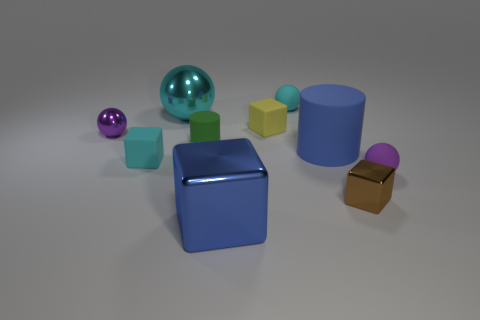Are there fewer large yellow blocks than blue matte things?
Offer a very short reply. Yes. There is a small object that is behind the brown block and in front of the tiny cyan matte cube; what is its material?
Make the answer very short. Rubber. Is there a blue rubber cylinder right of the small purple thing to the right of the large cyan metallic ball?
Offer a terse response. No. What number of small metallic cubes are the same color as the large matte cylinder?
Provide a short and direct response. 0. There is a block that is the same color as the large rubber cylinder; what material is it?
Keep it short and to the point. Metal. Is the tiny brown thing made of the same material as the cyan block?
Offer a terse response. No. There is a small purple metal thing; are there any tiny rubber things behind it?
Provide a short and direct response. Yes. There is a small brown object that is to the left of the small rubber sphere in front of the big cyan metallic sphere; what is its material?
Offer a very short reply. Metal. The cyan matte thing that is the same shape as the cyan shiny thing is what size?
Give a very brief answer. Small. Is the big metallic cube the same color as the large rubber cylinder?
Offer a terse response. Yes. 